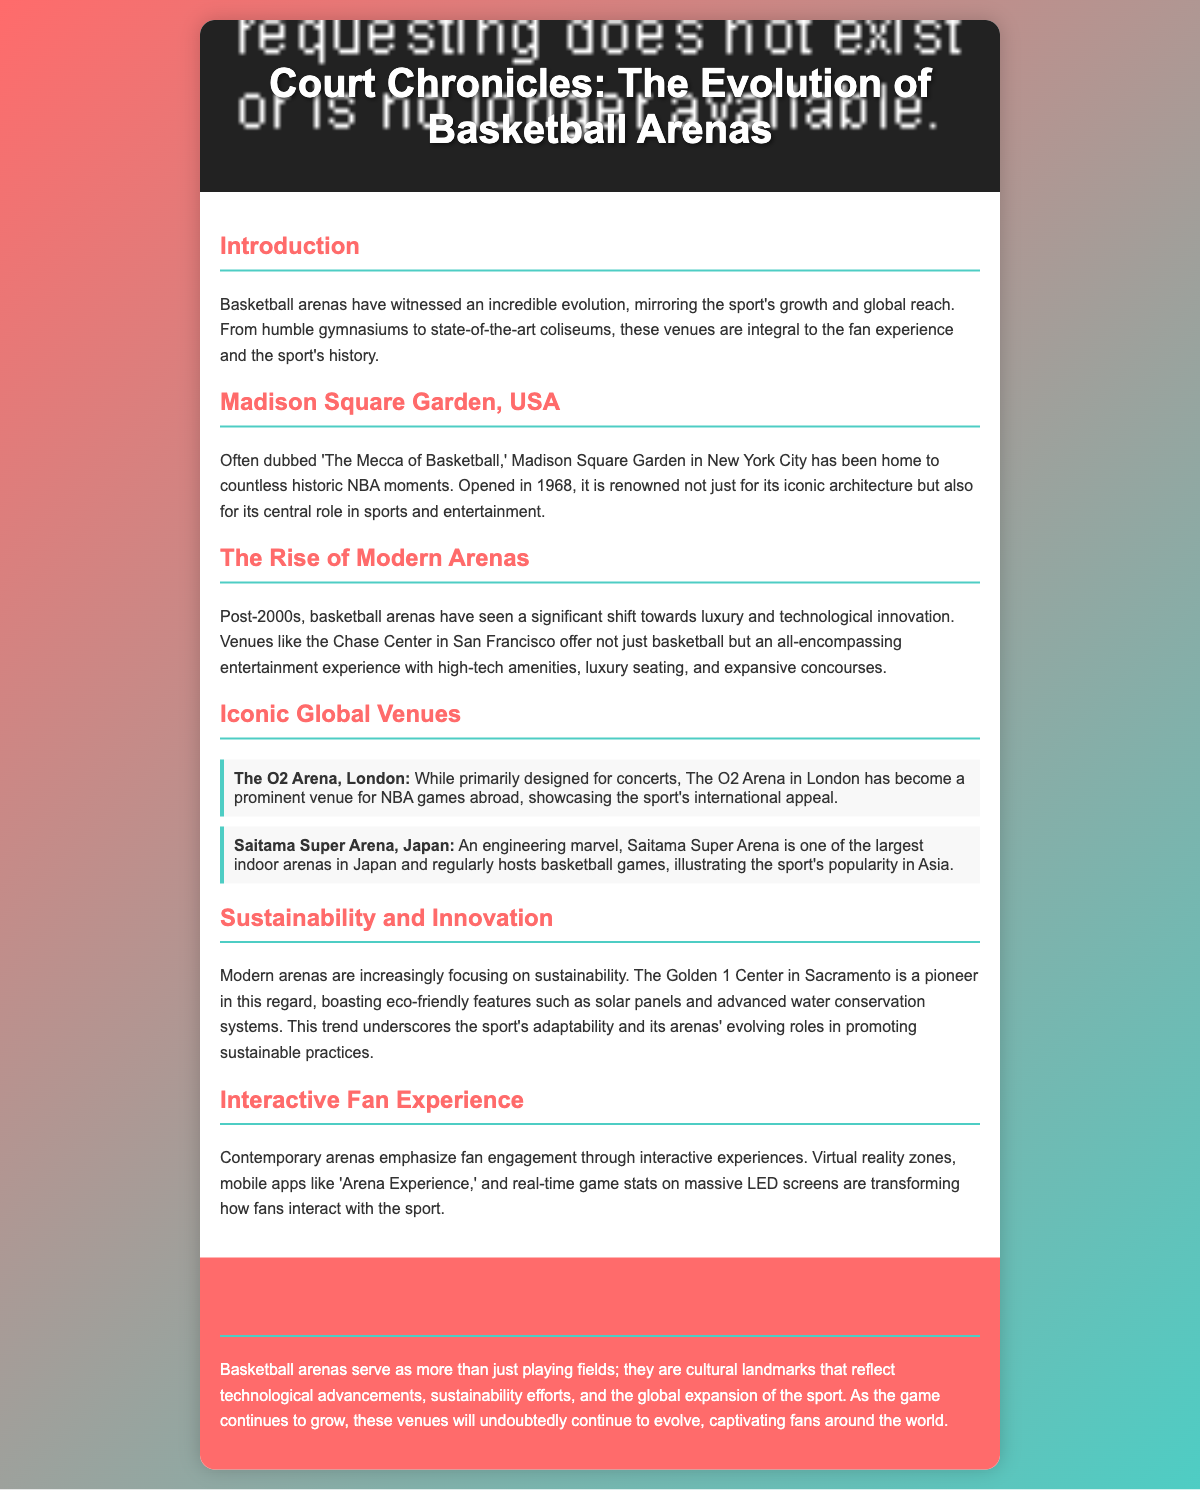What is the title of the playbill? The title of the playbill is stated at the top of the document.
Answer: Court Chronicles: The Evolution of Basketball Arenas and Iconic Venues Around the Globe When was Madison Square Garden opened? The opening year of Madison Square Garden is mentioned in the description of the venue.
Answer: 1968 What venue is known as 'The Mecca of Basketball'? The description specifically refers to Madison Square Garden with this nickname.
Answer: Madison Square Garden Which arena is considered a pioneer in sustainability? The document specifies the Golden 1 Center as a leader in eco-friendly features.
Answer: Golden 1 Center What is the architectural style of modern basketball arenas post-2000? The text highlights a specific characteristic of modern arenas in the context of their evolution.
Answer: Luxury and technological innovation Which country is home to the Saitama Super Arena? The location of Saitama Super Arena is mentioned in the document along with its significance.
Answer: Japan What is an example of an interactive fan experience mentioned? The document lists a specific feature that enhances fan interaction at contemporary arenas.
Answer: Virtual reality zones What color is used for the headers in the playbill? The color used for the headers can be found in the style definitions or visual description.
Answer: Red What feature does the Chase Center in San Francisco provide? The document outlines what the Chase Center offers beyond regular basketball games.
Answer: An all-encompassing entertainment experience 